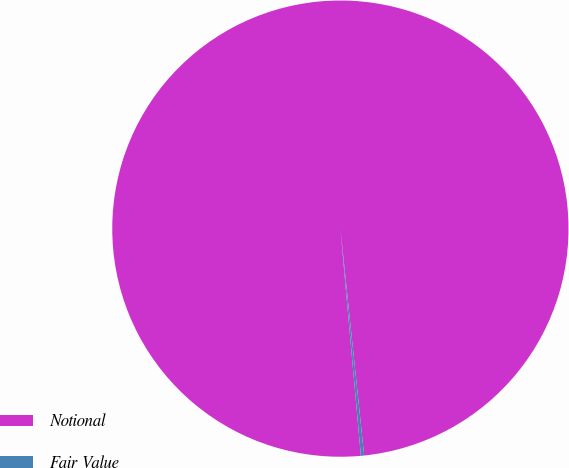<chart> <loc_0><loc_0><loc_500><loc_500><pie_chart><fcel>Notional<fcel>Fair Value<nl><fcel>99.77%<fcel>0.23%<nl></chart> 